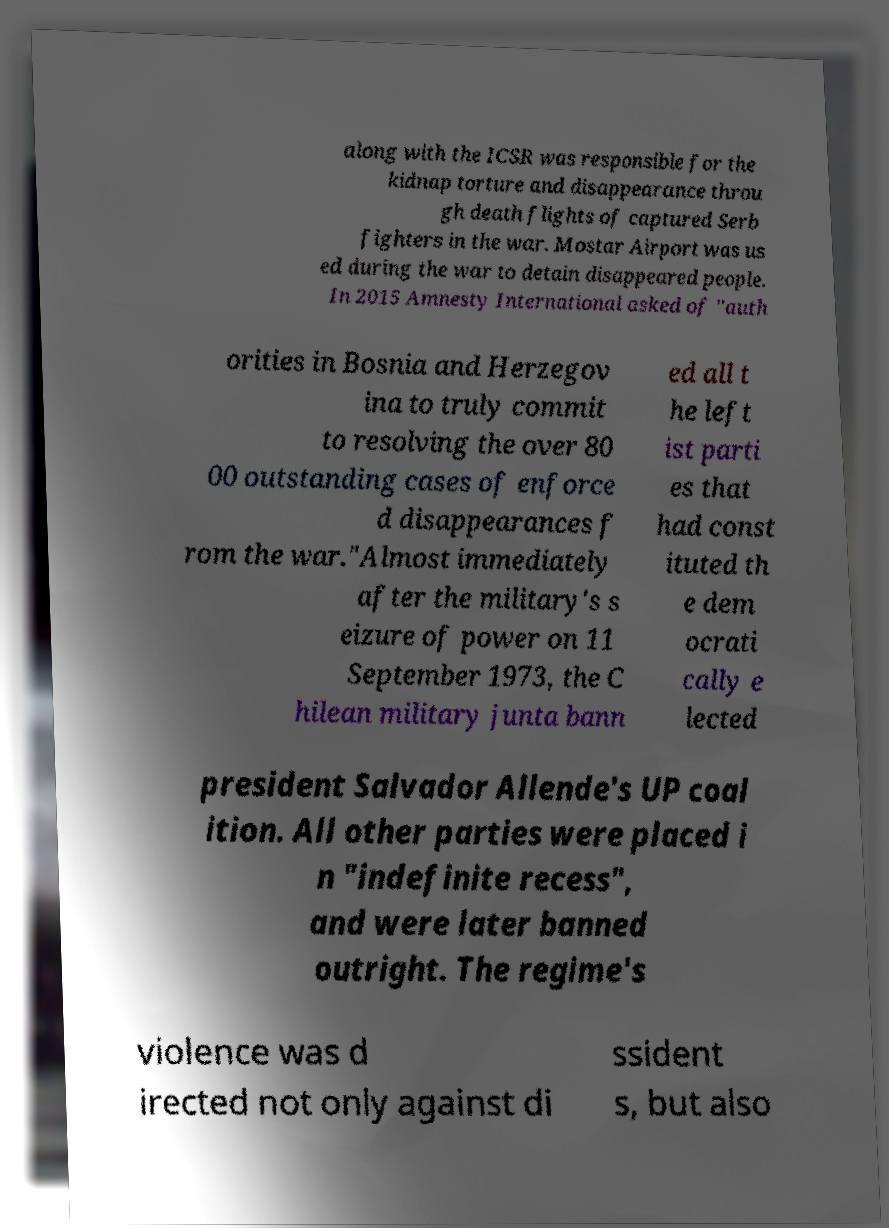Please read and relay the text visible in this image. What does it say? along with the ICSR was responsible for the kidnap torture and disappearance throu gh death flights of captured Serb fighters in the war. Mostar Airport was us ed during the war to detain disappeared people. In 2015 Amnesty International asked of "auth orities in Bosnia and Herzegov ina to truly commit to resolving the over 80 00 outstanding cases of enforce d disappearances f rom the war."Almost immediately after the military's s eizure of power on 11 September 1973, the C hilean military junta bann ed all t he left ist parti es that had const ituted th e dem ocrati cally e lected president Salvador Allende's UP coal ition. All other parties were placed i n "indefinite recess", and were later banned outright. The regime's violence was d irected not only against di ssident s, but also 